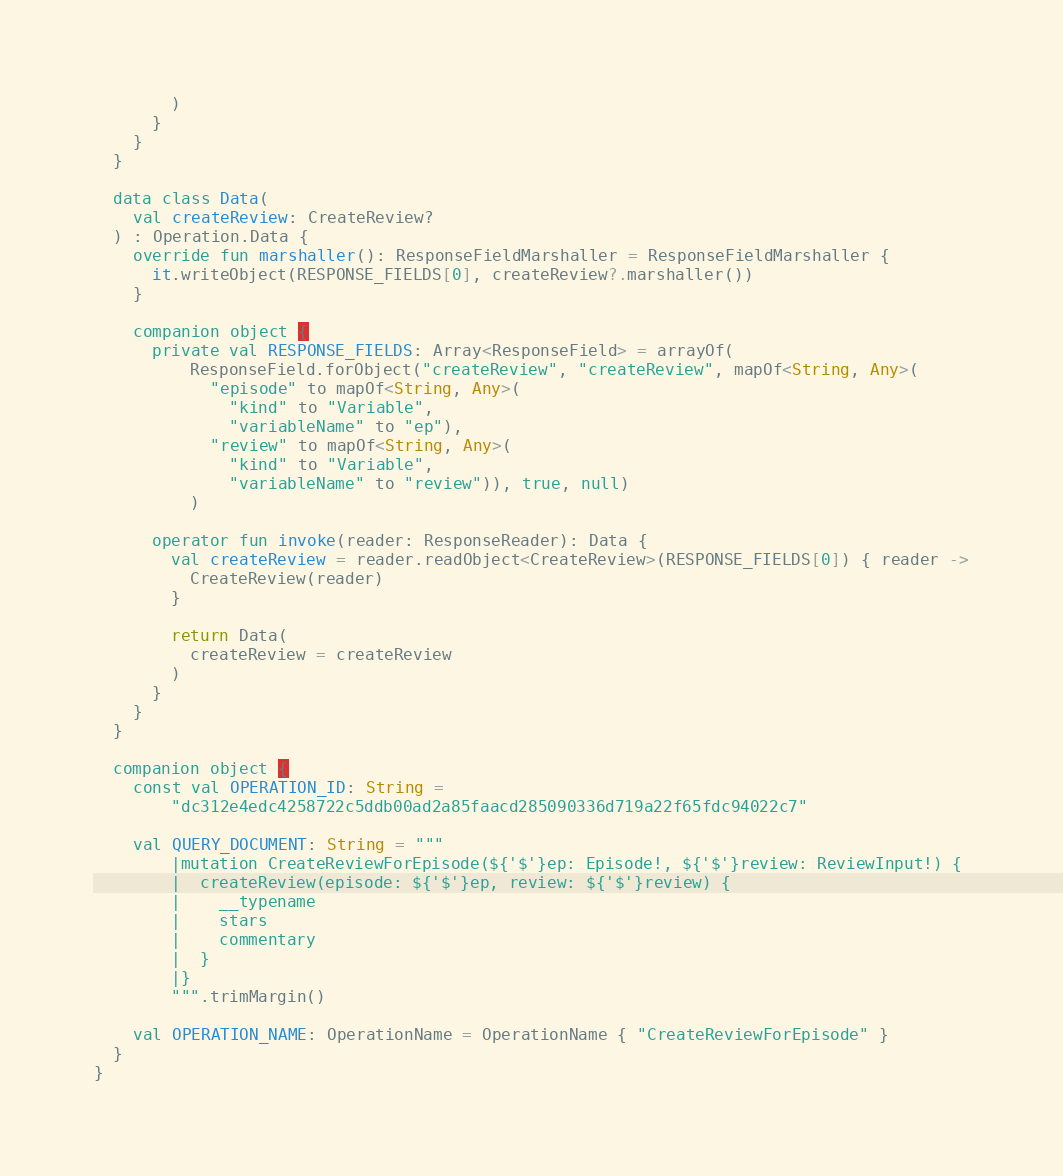<code> <loc_0><loc_0><loc_500><loc_500><_Kotlin_>        )
      }
    }
  }

  data class Data(
    val createReview: CreateReview?
  ) : Operation.Data {
    override fun marshaller(): ResponseFieldMarshaller = ResponseFieldMarshaller {
      it.writeObject(RESPONSE_FIELDS[0], createReview?.marshaller())
    }

    companion object {
      private val RESPONSE_FIELDS: Array<ResponseField> = arrayOf(
          ResponseField.forObject("createReview", "createReview", mapOf<String, Any>(
            "episode" to mapOf<String, Any>(
              "kind" to "Variable",
              "variableName" to "ep"),
            "review" to mapOf<String, Any>(
              "kind" to "Variable",
              "variableName" to "review")), true, null)
          )

      operator fun invoke(reader: ResponseReader): Data {
        val createReview = reader.readObject<CreateReview>(RESPONSE_FIELDS[0]) { reader ->
          CreateReview(reader)
        }

        return Data(
          createReview = createReview
        )
      }
    }
  }

  companion object {
    const val OPERATION_ID: String =
        "dc312e4edc4258722c5ddb00ad2a85faacd285090336d719a22f65fdc94022c7"

    val QUERY_DOCUMENT: String = """
        |mutation CreateReviewForEpisode(${'$'}ep: Episode!, ${'$'}review: ReviewInput!) {
        |  createReview(episode: ${'$'}ep, review: ${'$'}review) {
        |    __typename
        |    stars
        |    commentary
        |  }
        |}
        """.trimMargin()

    val OPERATION_NAME: OperationName = OperationName { "CreateReviewForEpisode" }
  }
}
</code> 